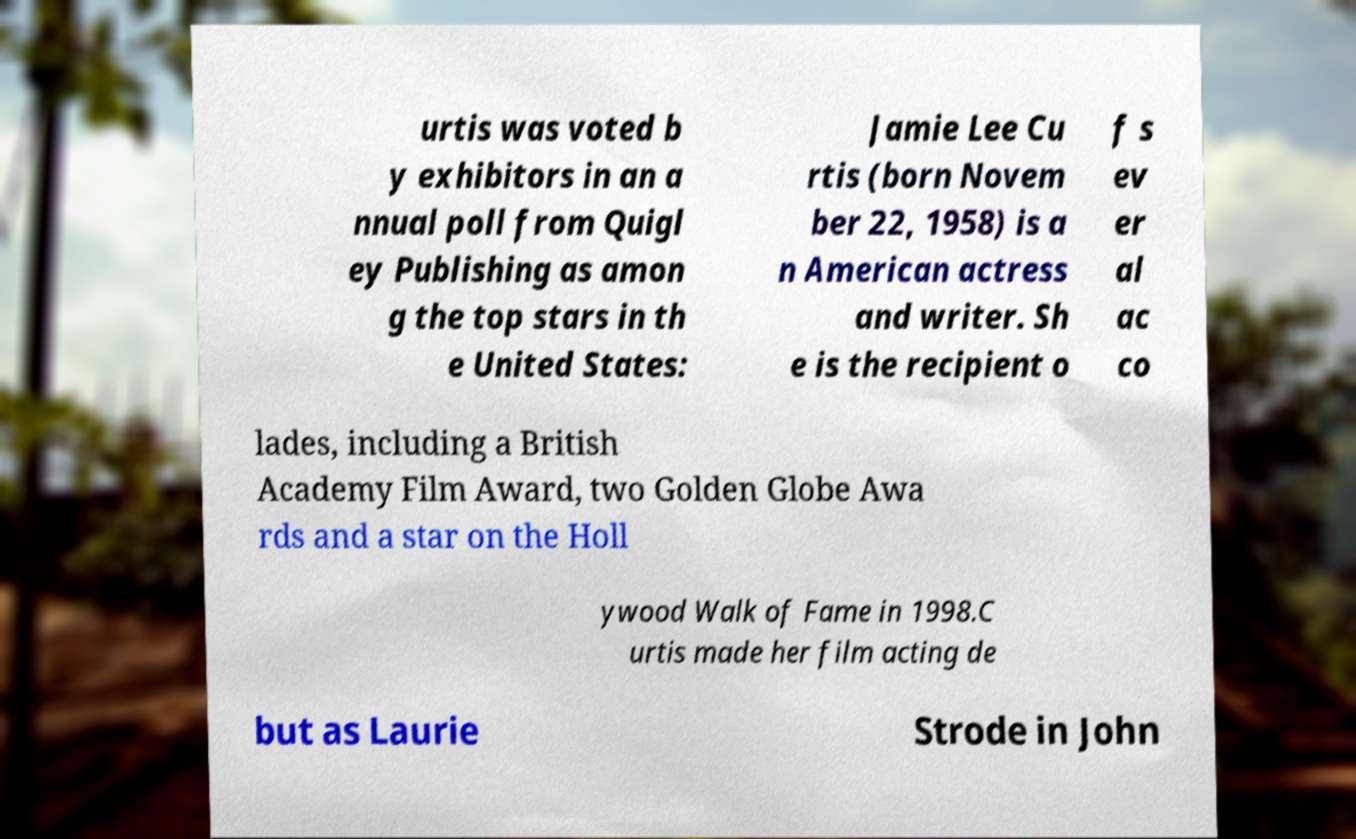What messages or text are displayed in this image? I need them in a readable, typed format. urtis was voted b y exhibitors in an a nnual poll from Quigl ey Publishing as amon g the top stars in th e United States: Jamie Lee Cu rtis (born Novem ber 22, 1958) is a n American actress and writer. Sh e is the recipient o f s ev er al ac co lades, including a British Academy Film Award, two Golden Globe Awa rds and a star on the Holl ywood Walk of Fame in 1998.C urtis made her film acting de but as Laurie Strode in John 